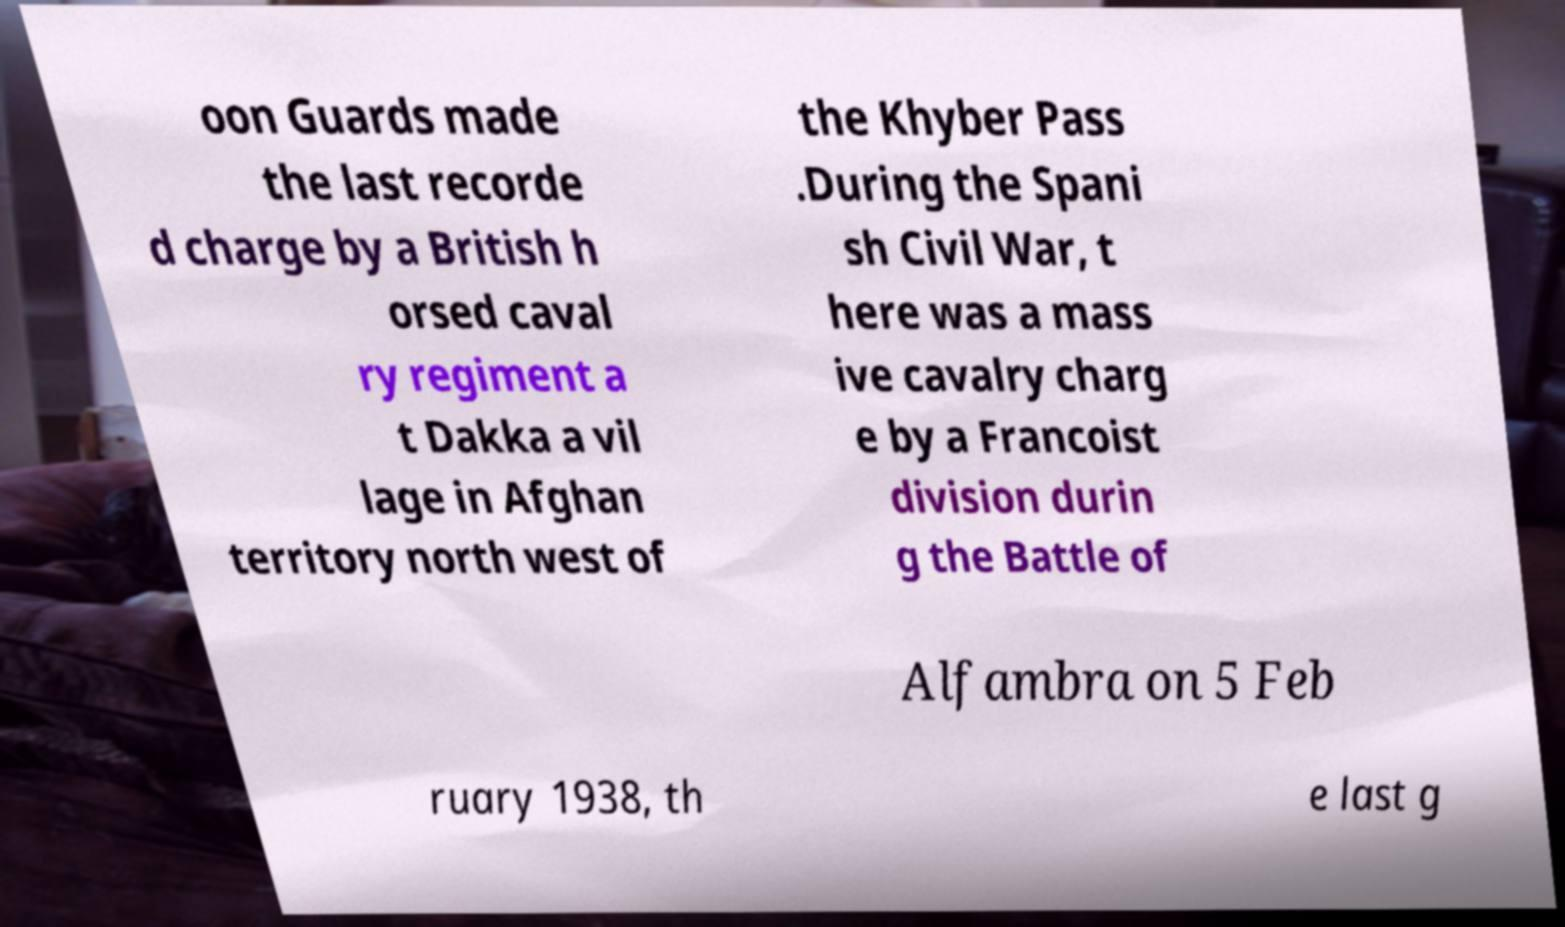Please identify and transcribe the text found in this image. oon Guards made the last recorde d charge by a British h orsed caval ry regiment a t Dakka a vil lage in Afghan territory north west of the Khyber Pass .During the Spani sh Civil War, t here was a mass ive cavalry charg e by a Francoist division durin g the Battle of Alfambra on 5 Feb ruary 1938, th e last g 